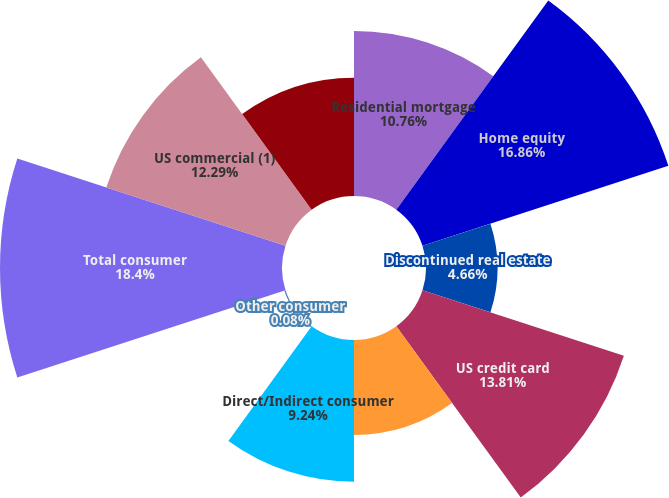Convert chart to OTSL. <chart><loc_0><loc_0><loc_500><loc_500><pie_chart><fcel>Residential mortgage<fcel>Home equity<fcel>Discontinued real estate<fcel>US credit card<fcel>Non-US credit card<fcel>Direct/Indirect consumer<fcel>Other consumer<fcel>Total consumer<fcel>US commercial (1)<fcel>Commercial real estate<nl><fcel>10.76%<fcel>16.86%<fcel>4.66%<fcel>13.81%<fcel>6.19%<fcel>9.24%<fcel>0.08%<fcel>18.39%<fcel>12.29%<fcel>7.71%<nl></chart> 